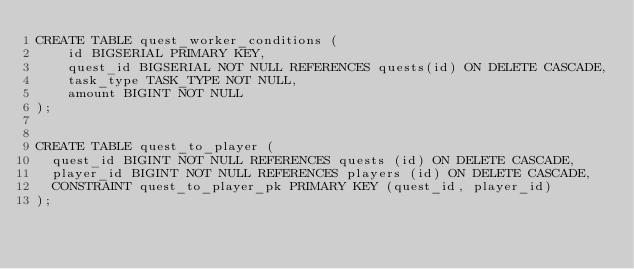Convert code to text. <code><loc_0><loc_0><loc_500><loc_500><_SQL_>CREATE TABLE quest_worker_conditions (
    id BIGSERIAL PRIMARY KEY,
    quest_id BIGSERIAL NOT NULL REFERENCES quests(id) ON DELETE CASCADE,
    task_type TASK_TYPE NOT NULL,
    amount BIGINT NOT NULL
);


CREATE TABLE quest_to_player (
  quest_id BIGINT NOT NULL REFERENCES quests (id) ON DELETE CASCADE,
  player_id BIGINT NOT NULL REFERENCES players (id) ON DELETE CASCADE,
  CONSTRAINT quest_to_player_pk PRIMARY KEY (quest_id, player_id)
);
</code> 